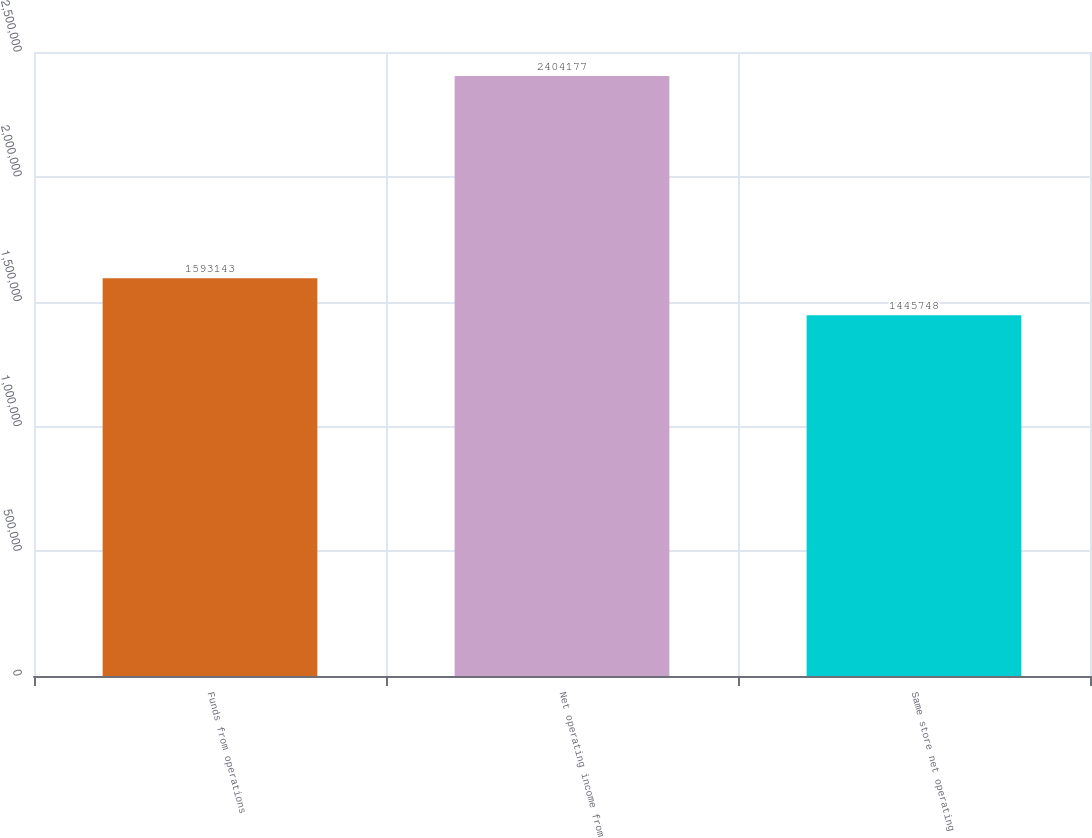<chart> <loc_0><loc_0><loc_500><loc_500><bar_chart><fcel>Funds from operations<fcel>Net operating income from<fcel>Same store net operating<nl><fcel>1.59314e+06<fcel>2.40418e+06<fcel>1.44575e+06<nl></chart> 